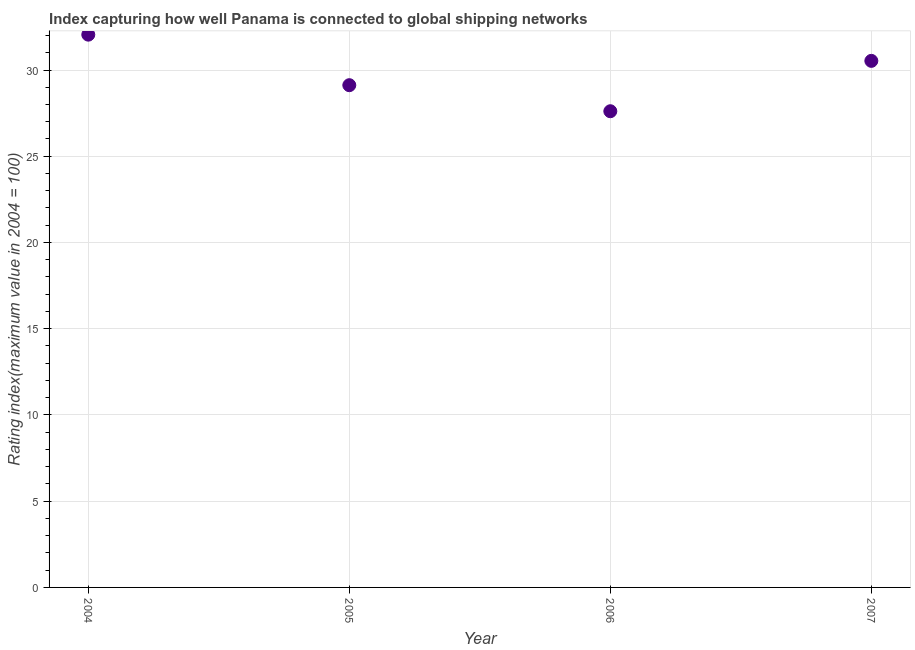What is the liner shipping connectivity index in 2005?
Provide a short and direct response. 29.12. Across all years, what is the maximum liner shipping connectivity index?
Give a very brief answer. 32.05. Across all years, what is the minimum liner shipping connectivity index?
Offer a very short reply. 27.61. In which year was the liner shipping connectivity index maximum?
Provide a succinct answer. 2004. What is the sum of the liner shipping connectivity index?
Provide a short and direct response. 119.31. What is the difference between the liner shipping connectivity index in 2005 and 2006?
Your answer should be very brief. 1.51. What is the average liner shipping connectivity index per year?
Your answer should be compact. 29.83. What is the median liner shipping connectivity index?
Keep it short and to the point. 29.83. What is the ratio of the liner shipping connectivity index in 2004 to that in 2006?
Keep it short and to the point. 1.16. What is the difference between the highest and the second highest liner shipping connectivity index?
Ensure brevity in your answer.  1.52. Is the sum of the liner shipping connectivity index in 2004 and 2005 greater than the maximum liner shipping connectivity index across all years?
Your response must be concise. Yes. What is the difference between the highest and the lowest liner shipping connectivity index?
Provide a succinct answer. 4.44. In how many years, is the liner shipping connectivity index greater than the average liner shipping connectivity index taken over all years?
Offer a terse response. 2. How many dotlines are there?
Provide a succinct answer. 1. What is the difference between two consecutive major ticks on the Y-axis?
Your answer should be very brief. 5. Does the graph contain any zero values?
Offer a terse response. No. Does the graph contain grids?
Provide a short and direct response. Yes. What is the title of the graph?
Your answer should be compact. Index capturing how well Panama is connected to global shipping networks. What is the label or title of the X-axis?
Your answer should be compact. Year. What is the label or title of the Y-axis?
Your answer should be compact. Rating index(maximum value in 2004 = 100). What is the Rating index(maximum value in 2004 = 100) in 2004?
Offer a very short reply. 32.05. What is the Rating index(maximum value in 2004 = 100) in 2005?
Ensure brevity in your answer.  29.12. What is the Rating index(maximum value in 2004 = 100) in 2006?
Give a very brief answer. 27.61. What is the Rating index(maximum value in 2004 = 100) in 2007?
Ensure brevity in your answer.  30.53. What is the difference between the Rating index(maximum value in 2004 = 100) in 2004 and 2005?
Provide a short and direct response. 2.93. What is the difference between the Rating index(maximum value in 2004 = 100) in 2004 and 2006?
Your response must be concise. 4.44. What is the difference between the Rating index(maximum value in 2004 = 100) in 2004 and 2007?
Give a very brief answer. 1.52. What is the difference between the Rating index(maximum value in 2004 = 100) in 2005 and 2006?
Give a very brief answer. 1.51. What is the difference between the Rating index(maximum value in 2004 = 100) in 2005 and 2007?
Your answer should be very brief. -1.41. What is the difference between the Rating index(maximum value in 2004 = 100) in 2006 and 2007?
Your response must be concise. -2.92. What is the ratio of the Rating index(maximum value in 2004 = 100) in 2004 to that in 2005?
Provide a succinct answer. 1.1. What is the ratio of the Rating index(maximum value in 2004 = 100) in 2004 to that in 2006?
Make the answer very short. 1.16. What is the ratio of the Rating index(maximum value in 2004 = 100) in 2005 to that in 2006?
Give a very brief answer. 1.05. What is the ratio of the Rating index(maximum value in 2004 = 100) in 2005 to that in 2007?
Your answer should be very brief. 0.95. What is the ratio of the Rating index(maximum value in 2004 = 100) in 2006 to that in 2007?
Offer a very short reply. 0.9. 